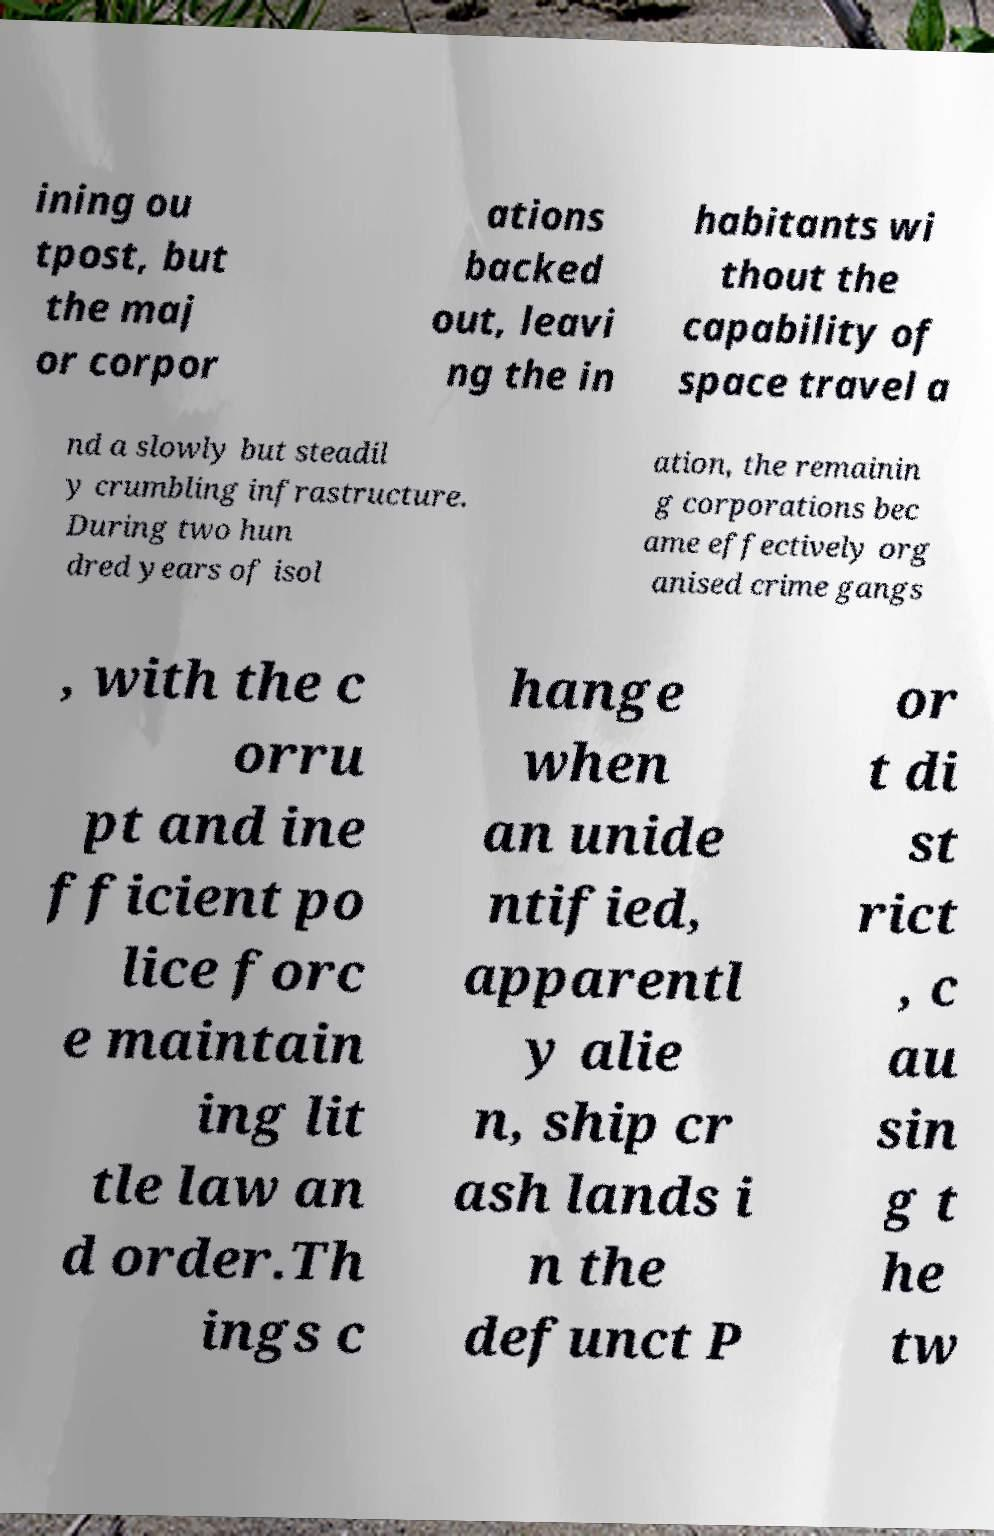Please identify and transcribe the text found in this image. ining ou tpost, but the maj or corpor ations backed out, leavi ng the in habitants wi thout the capability of space travel a nd a slowly but steadil y crumbling infrastructure. During two hun dred years of isol ation, the remainin g corporations bec ame effectively org anised crime gangs , with the c orru pt and ine fficient po lice forc e maintain ing lit tle law an d order.Th ings c hange when an unide ntified, apparentl y alie n, ship cr ash lands i n the defunct P or t di st rict , c au sin g t he tw 